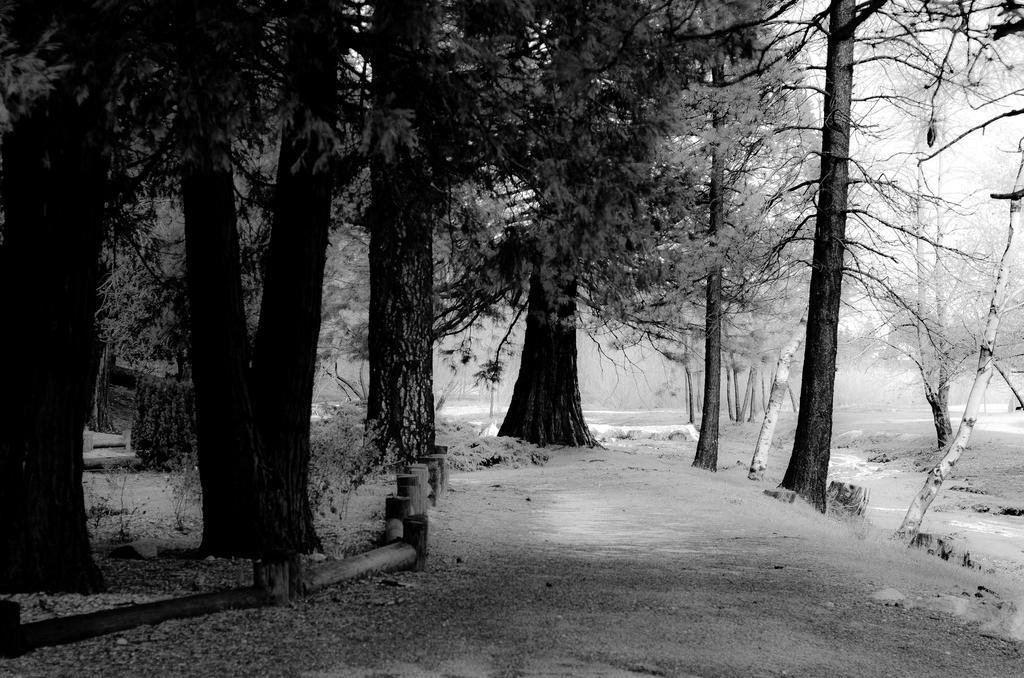Describe this image in one or two sentences. We can see trees, plants and snow. In the background we can see sky. 